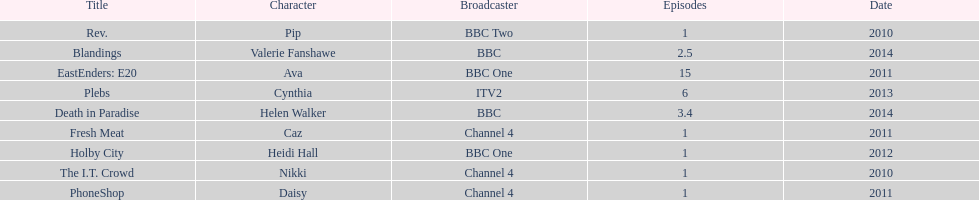Blandings and death in paradise both aired on which broadcaster? BBC. 